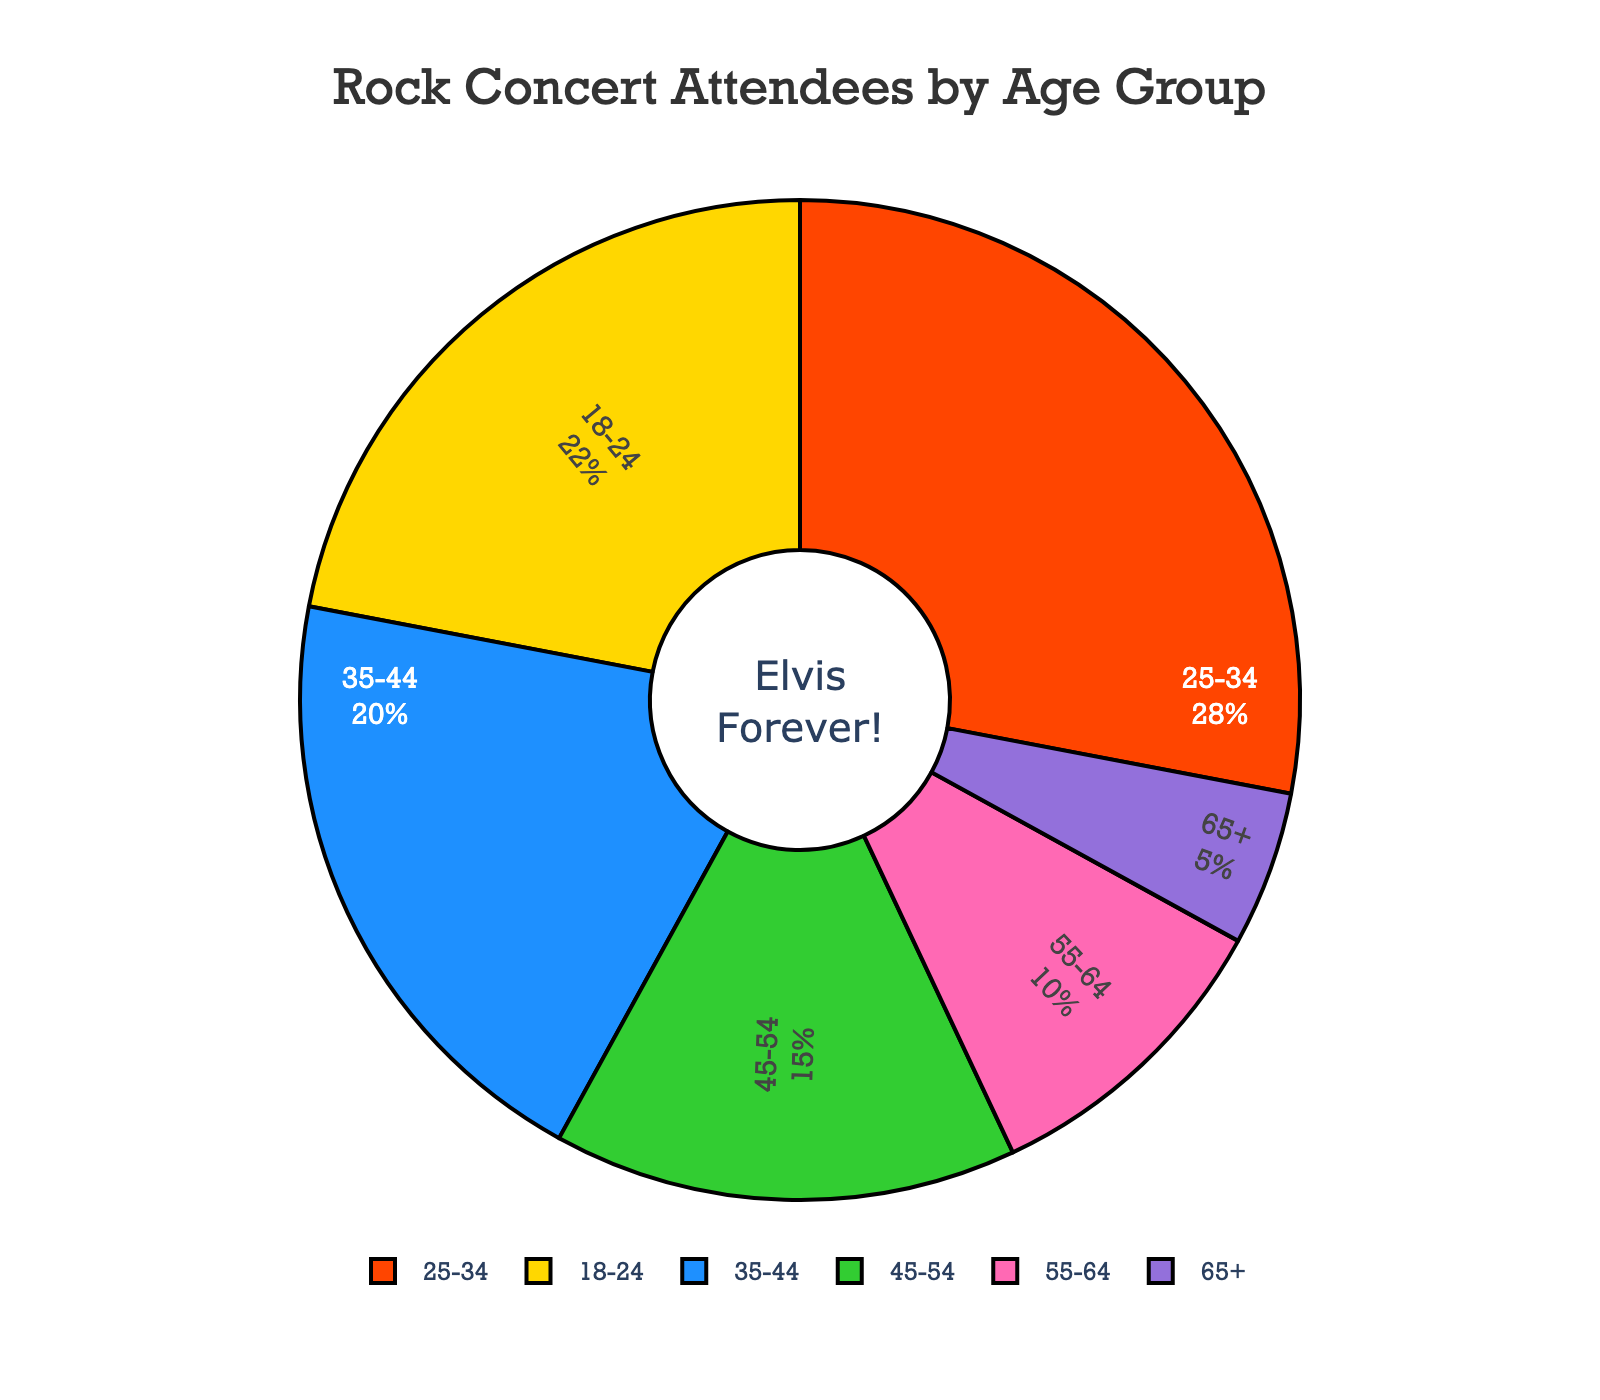Which age group has the highest percentage of concert attendees? To find the age group with the highest percentage, check the figures for each group in the pie chart. The 25-34 age group has the largest portion.
Answer: 25-34 Which two age groups combined make up more than 50% of the concert attendees? Identify the percentages of each age group and combine them logically to see which pairs exceed 50%. The 18-24 group (22%) and 25-34 group (28%) together make 50%, so any combination that includes these two surpasses 50%.
Answer: 18-24 and 25-34 How much larger is the 25-34 age group's percentage compared to the 55-64 age group? Subtract the percentage of the 55-64 age group from the 25-34 age group: 28% - 10% = 18%.
Answer: 18% What percentage of the concert attendees are 45 years or older? Sum the percentages of the 45-54, 55-64, and 65+ age groups: 15% + 10% + 5% = 30%.
Answer: 30% Which age group represents the smallest percentage of concert attendees? Look for the smallest percentage value among all groups. The 65+ age group, with 5%, is the smallest.
Answer: 65+ What is the combined percentage of concert attendees under 35 years? Sum the percentages of the 18-24 and 25-34 age groups: 22% + 28% = 50%.
Answer: 50% Between the 35-44 and 45-54 age groups, which one has a higher percentage of attendees? Compare the percentages of the two age groups. The 35-44 group (20%) is higher than the 45-54 group (15%).
Answer: 35-44 What is the average (mean) percentage of the 25-34, 55-64, and 65+ age groups? Sum the percentages and then divide by the number of groups: (28% + 10% + 5%) / 3 = 43% / 3 ≈ 14.33%.
Answer: ~14.33% How much more is the percentage of the 18-24 age group compared to the 65+ age group? Subtract the percentage of the 65+ age group from the 18-24 age group: 22% - 5% = 17%.
Answer: 17% What proportion of attendees are younger than 45 years old? Sum the percentages of the 18-24, 25-34, and 35-44 age groups: 22% + 28% + 20% = 70%.
Answer: 70% 